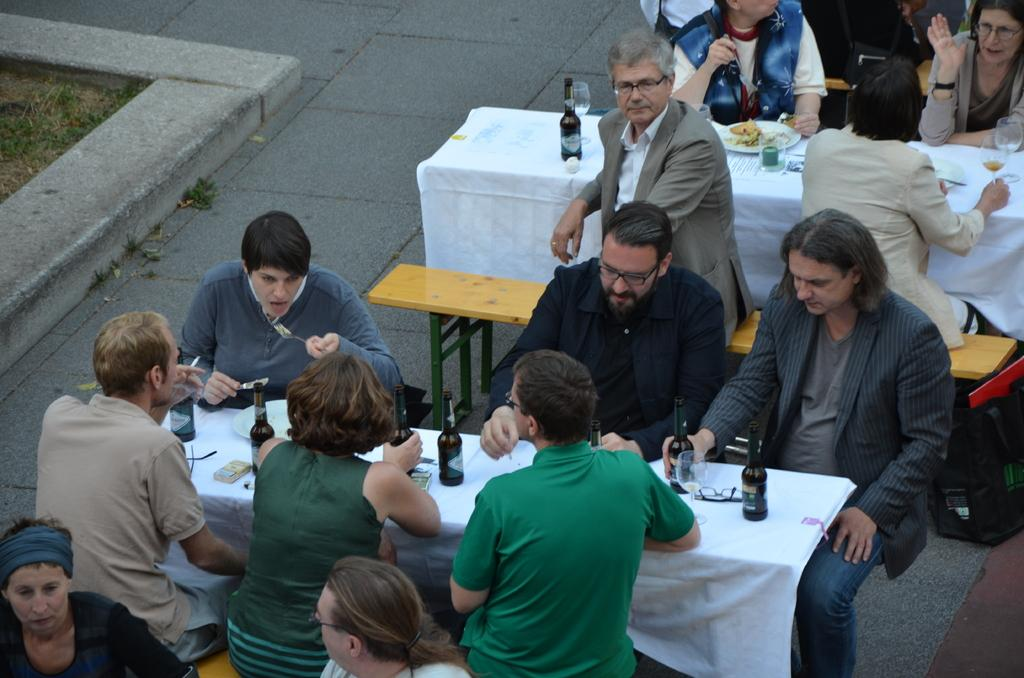What are the people in the image doing? The persons in the image are sitting on chairs. What is present in the image besides the chairs? There is a table in the image. What items can be seen on the table? There are bottles and glasses on the table. What other type of seating is available in the image? There is a bench in the image. What type of sign can be seen on the street in the image? There is no street or sign present in the image; it features persons sitting on chairs, a table, bottles, glasses, and a bench. How is the glue being used by the persons in the image? There is no glue present in the image; the persons are simply sitting on chairs. 